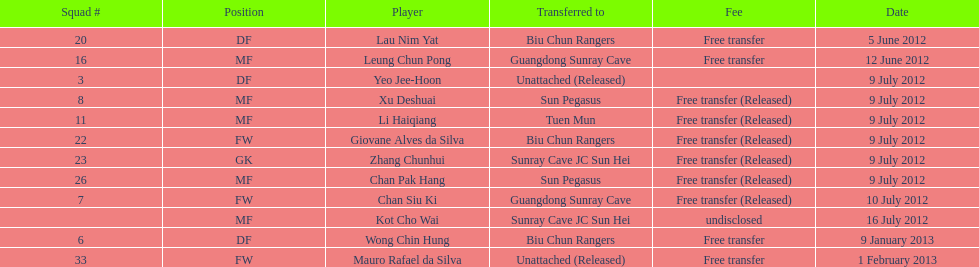How many consecutive players were released on july 9? 6. 